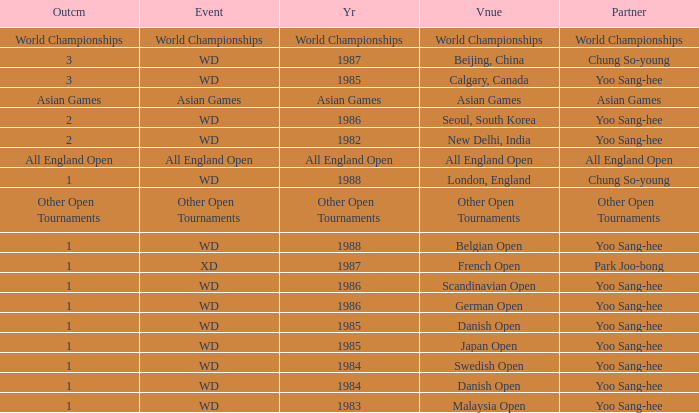In what year did yoo sang-hee participate as a partner in the german open? 1986.0. 